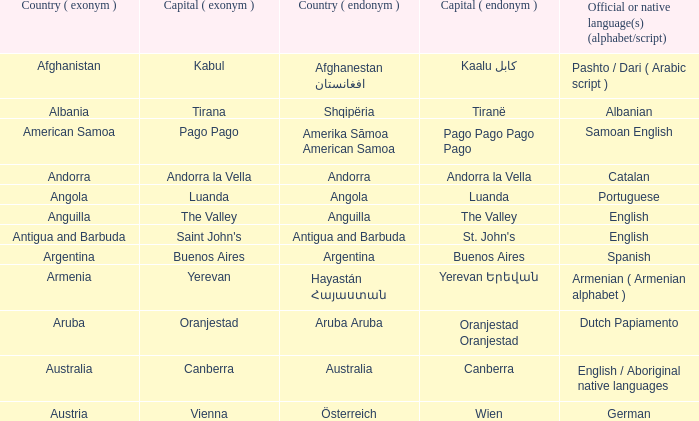Can you tell me the total number of australian capital cities? 1.0. I'm looking to parse the entire table for insights. Could you assist me with that? {'header': ['Country ( exonym )', 'Capital ( exonym )', 'Country ( endonym )', 'Capital ( endonym )', 'Official or native language(s) (alphabet/script)'], 'rows': [['Afghanistan', 'Kabul', 'Afghanestan افغانستان', 'Kaalu كابل', 'Pashto / Dari ( Arabic script )'], ['Albania', 'Tirana', 'Shqipëria', 'Tiranë', 'Albanian'], ['American Samoa', 'Pago Pago', 'Amerika Sāmoa American Samoa', 'Pago Pago Pago Pago', 'Samoan English'], ['Andorra', 'Andorra la Vella', 'Andorra', 'Andorra la Vella', 'Catalan'], ['Angola', 'Luanda', 'Angola', 'Luanda', 'Portuguese'], ['Anguilla', 'The Valley', 'Anguilla', 'The Valley', 'English'], ['Antigua and Barbuda', "Saint John's", 'Antigua and Barbuda', "St. John's", 'English'], ['Argentina', 'Buenos Aires', 'Argentina', 'Buenos Aires', 'Spanish'], ['Armenia', 'Yerevan', 'Hayastán Հայաստան', 'Yerevan Երեվան', 'Armenian ( Armenian alphabet )'], ['Aruba', 'Oranjestad', 'Aruba Aruba', 'Oranjestad Oranjestad', 'Dutch Papiamento'], ['Australia', 'Canberra', 'Australia', 'Canberra', 'English / Aboriginal native languages'], ['Austria', 'Vienna', 'Österreich', 'Wien', 'German']]} 